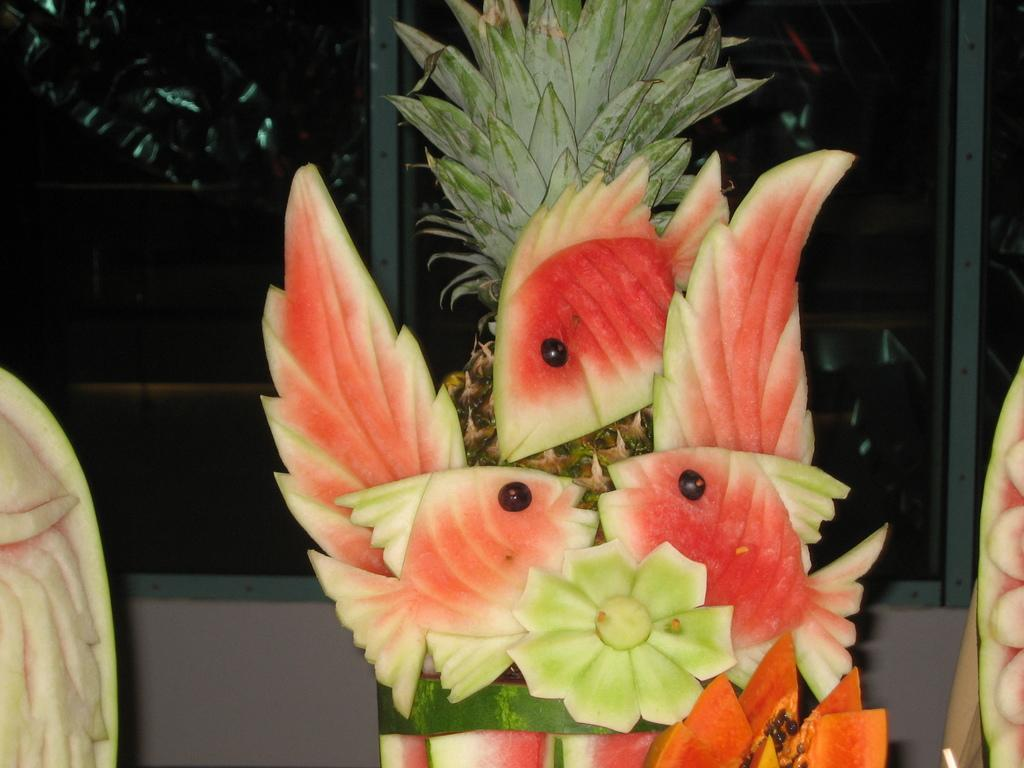What type of craft is depicted in the image? There is a fruit craft in the image. What specific fruits are used to create the craft? The craft features fish made of watermelon. What other fruit is present in the image? There is a pineapple in the image. What type of structure can be seen in the background of the image? There is a wall in the image, and windows are visible on it. How many basketballs are visible in the image? There are no basketballs present in the image. Can you describe the yak in the image? There is no yak in the image. 